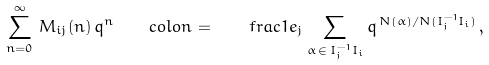Convert formula to latex. <formula><loc_0><loc_0><loc_500><loc_500>\sum _ { n = 0 } ^ { \infty } \, M _ { i j } ( n ) \, q ^ { n } \ \ \ c o l o n = \quad f r a c { 1 } { e _ { j } } \sum _ { \alpha \, \in \, I _ { j } ^ { - 1 } I _ { i } } q ^ { \, N ( \alpha ) / N ( I _ { j } ^ { - 1 } I _ { i } ) } \, ,</formula> 